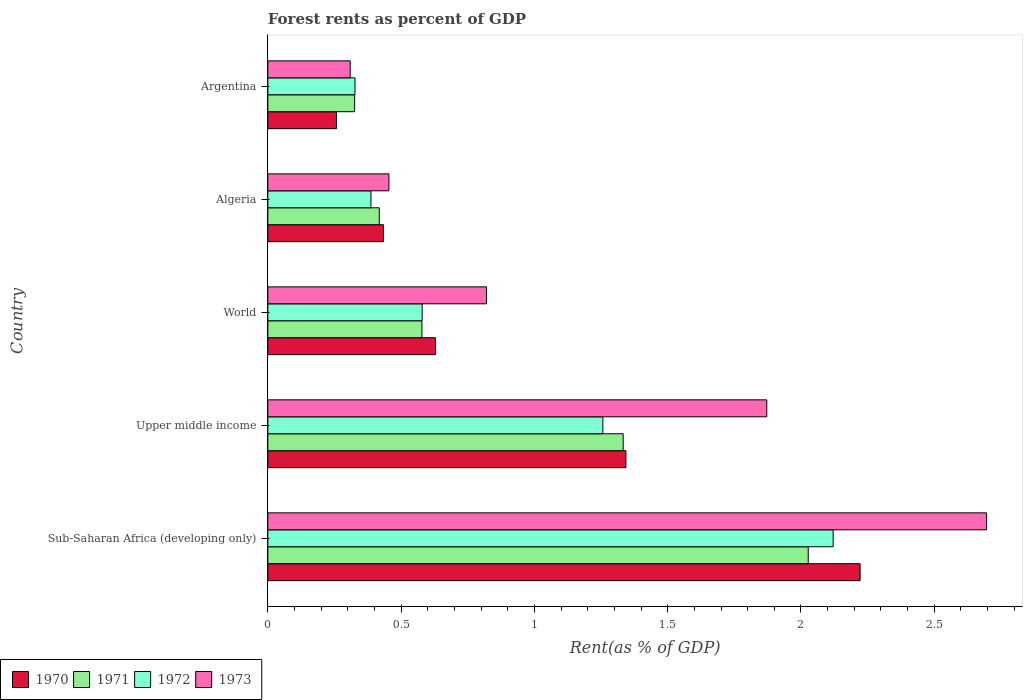How many different coloured bars are there?
Your answer should be very brief. 4. Are the number of bars on each tick of the Y-axis equal?
Provide a succinct answer. Yes. How many bars are there on the 4th tick from the top?
Offer a very short reply. 4. What is the label of the 4th group of bars from the top?
Your answer should be very brief. Upper middle income. What is the forest rent in 1973 in Sub-Saharan Africa (developing only)?
Offer a very short reply. 2.7. Across all countries, what is the maximum forest rent in 1973?
Ensure brevity in your answer.  2.7. Across all countries, what is the minimum forest rent in 1973?
Keep it short and to the point. 0.31. In which country was the forest rent in 1970 maximum?
Keep it short and to the point. Sub-Saharan Africa (developing only). What is the total forest rent in 1972 in the graph?
Keep it short and to the point. 4.67. What is the difference between the forest rent in 1972 in Argentina and that in Upper middle income?
Keep it short and to the point. -0.93. What is the difference between the forest rent in 1973 in World and the forest rent in 1972 in Upper middle income?
Offer a terse response. -0.44. What is the average forest rent in 1973 per country?
Provide a short and direct response. 1.23. What is the difference between the forest rent in 1972 and forest rent in 1971 in Algeria?
Offer a very short reply. -0.03. In how many countries, is the forest rent in 1973 greater than 1.6 %?
Offer a very short reply. 2. What is the ratio of the forest rent in 1972 in Argentina to that in Upper middle income?
Ensure brevity in your answer.  0.26. Is the forest rent in 1971 in Algeria less than that in Argentina?
Ensure brevity in your answer.  No. What is the difference between the highest and the second highest forest rent in 1973?
Offer a very short reply. 0.82. What is the difference between the highest and the lowest forest rent in 1970?
Your response must be concise. 1.96. Is it the case that in every country, the sum of the forest rent in 1971 and forest rent in 1970 is greater than the sum of forest rent in 1973 and forest rent in 1972?
Keep it short and to the point. No. What does the 3rd bar from the bottom in World represents?
Offer a very short reply. 1972. How many bars are there?
Ensure brevity in your answer.  20. Are all the bars in the graph horizontal?
Your answer should be compact. Yes. How many countries are there in the graph?
Make the answer very short. 5. What is the difference between two consecutive major ticks on the X-axis?
Make the answer very short. 0.5. Does the graph contain grids?
Your answer should be very brief. No. How are the legend labels stacked?
Provide a succinct answer. Horizontal. What is the title of the graph?
Your answer should be very brief. Forest rents as percent of GDP. Does "1989" appear as one of the legend labels in the graph?
Offer a terse response. No. What is the label or title of the X-axis?
Your response must be concise. Rent(as % of GDP). What is the Rent(as % of GDP) of 1970 in Sub-Saharan Africa (developing only)?
Your answer should be very brief. 2.22. What is the Rent(as % of GDP) in 1971 in Sub-Saharan Africa (developing only)?
Your answer should be very brief. 2.03. What is the Rent(as % of GDP) in 1972 in Sub-Saharan Africa (developing only)?
Your response must be concise. 2.12. What is the Rent(as % of GDP) of 1973 in Sub-Saharan Africa (developing only)?
Give a very brief answer. 2.7. What is the Rent(as % of GDP) of 1970 in Upper middle income?
Give a very brief answer. 1.34. What is the Rent(as % of GDP) in 1971 in Upper middle income?
Ensure brevity in your answer.  1.33. What is the Rent(as % of GDP) in 1972 in Upper middle income?
Your answer should be very brief. 1.26. What is the Rent(as % of GDP) in 1973 in Upper middle income?
Provide a short and direct response. 1.87. What is the Rent(as % of GDP) of 1970 in World?
Your answer should be compact. 0.63. What is the Rent(as % of GDP) in 1971 in World?
Offer a very short reply. 0.58. What is the Rent(as % of GDP) of 1972 in World?
Provide a succinct answer. 0.58. What is the Rent(as % of GDP) of 1973 in World?
Provide a succinct answer. 0.82. What is the Rent(as % of GDP) in 1970 in Algeria?
Offer a very short reply. 0.43. What is the Rent(as % of GDP) in 1971 in Algeria?
Provide a succinct answer. 0.42. What is the Rent(as % of GDP) of 1972 in Algeria?
Ensure brevity in your answer.  0.39. What is the Rent(as % of GDP) in 1973 in Algeria?
Provide a succinct answer. 0.45. What is the Rent(as % of GDP) in 1970 in Argentina?
Make the answer very short. 0.26. What is the Rent(as % of GDP) of 1971 in Argentina?
Provide a succinct answer. 0.33. What is the Rent(as % of GDP) in 1972 in Argentina?
Your response must be concise. 0.33. What is the Rent(as % of GDP) of 1973 in Argentina?
Offer a terse response. 0.31. Across all countries, what is the maximum Rent(as % of GDP) of 1970?
Your answer should be compact. 2.22. Across all countries, what is the maximum Rent(as % of GDP) of 1971?
Offer a terse response. 2.03. Across all countries, what is the maximum Rent(as % of GDP) in 1972?
Provide a succinct answer. 2.12. Across all countries, what is the maximum Rent(as % of GDP) in 1973?
Your response must be concise. 2.7. Across all countries, what is the minimum Rent(as % of GDP) of 1970?
Your answer should be very brief. 0.26. Across all countries, what is the minimum Rent(as % of GDP) of 1971?
Your answer should be very brief. 0.33. Across all countries, what is the minimum Rent(as % of GDP) of 1972?
Your response must be concise. 0.33. Across all countries, what is the minimum Rent(as % of GDP) in 1973?
Provide a succinct answer. 0.31. What is the total Rent(as % of GDP) in 1970 in the graph?
Make the answer very short. 4.89. What is the total Rent(as % of GDP) in 1971 in the graph?
Make the answer very short. 4.68. What is the total Rent(as % of GDP) of 1972 in the graph?
Offer a terse response. 4.67. What is the total Rent(as % of GDP) of 1973 in the graph?
Keep it short and to the point. 6.15. What is the difference between the Rent(as % of GDP) in 1970 in Sub-Saharan Africa (developing only) and that in Upper middle income?
Ensure brevity in your answer.  0.88. What is the difference between the Rent(as % of GDP) of 1971 in Sub-Saharan Africa (developing only) and that in Upper middle income?
Keep it short and to the point. 0.69. What is the difference between the Rent(as % of GDP) in 1972 in Sub-Saharan Africa (developing only) and that in Upper middle income?
Provide a short and direct response. 0.86. What is the difference between the Rent(as % of GDP) of 1973 in Sub-Saharan Africa (developing only) and that in Upper middle income?
Your answer should be compact. 0.82. What is the difference between the Rent(as % of GDP) of 1970 in Sub-Saharan Africa (developing only) and that in World?
Your answer should be compact. 1.59. What is the difference between the Rent(as % of GDP) of 1971 in Sub-Saharan Africa (developing only) and that in World?
Offer a terse response. 1.45. What is the difference between the Rent(as % of GDP) in 1972 in Sub-Saharan Africa (developing only) and that in World?
Ensure brevity in your answer.  1.54. What is the difference between the Rent(as % of GDP) of 1973 in Sub-Saharan Africa (developing only) and that in World?
Your response must be concise. 1.88. What is the difference between the Rent(as % of GDP) in 1970 in Sub-Saharan Africa (developing only) and that in Algeria?
Provide a succinct answer. 1.79. What is the difference between the Rent(as % of GDP) in 1971 in Sub-Saharan Africa (developing only) and that in Algeria?
Make the answer very short. 1.61. What is the difference between the Rent(as % of GDP) of 1972 in Sub-Saharan Africa (developing only) and that in Algeria?
Provide a succinct answer. 1.73. What is the difference between the Rent(as % of GDP) of 1973 in Sub-Saharan Africa (developing only) and that in Algeria?
Your response must be concise. 2.24. What is the difference between the Rent(as % of GDP) in 1970 in Sub-Saharan Africa (developing only) and that in Argentina?
Your answer should be very brief. 1.96. What is the difference between the Rent(as % of GDP) of 1971 in Sub-Saharan Africa (developing only) and that in Argentina?
Your response must be concise. 1.7. What is the difference between the Rent(as % of GDP) of 1972 in Sub-Saharan Africa (developing only) and that in Argentina?
Make the answer very short. 1.79. What is the difference between the Rent(as % of GDP) in 1973 in Sub-Saharan Africa (developing only) and that in Argentina?
Offer a terse response. 2.39. What is the difference between the Rent(as % of GDP) of 1970 in Upper middle income and that in World?
Provide a short and direct response. 0.71. What is the difference between the Rent(as % of GDP) of 1971 in Upper middle income and that in World?
Your answer should be compact. 0.76. What is the difference between the Rent(as % of GDP) in 1972 in Upper middle income and that in World?
Give a very brief answer. 0.68. What is the difference between the Rent(as % of GDP) in 1973 in Upper middle income and that in World?
Offer a very short reply. 1.05. What is the difference between the Rent(as % of GDP) of 1970 in Upper middle income and that in Algeria?
Make the answer very short. 0.91. What is the difference between the Rent(as % of GDP) in 1971 in Upper middle income and that in Algeria?
Provide a short and direct response. 0.92. What is the difference between the Rent(as % of GDP) in 1972 in Upper middle income and that in Algeria?
Make the answer very short. 0.87. What is the difference between the Rent(as % of GDP) of 1973 in Upper middle income and that in Algeria?
Offer a terse response. 1.42. What is the difference between the Rent(as % of GDP) of 1970 in Upper middle income and that in Argentina?
Your answer should be very brief. 1.09. What is the difference between the Rent(as % of GDP) of 1971 in Upper middle income and that in Argentina?
Offer a very short reply. 1.01. What is the difference between the Rent(as % of GDP) of 1972 in Upper middle income and that in Argentina?
Make the answer very short. 0.93. What is the difference between the Rent(as % of GDP) in 1973 in Upper middle income and that in Argentina?
Keep it short and to the point. 1.56. What is the difference between the Rent(as % of GDP) in 1970 in World and that in Algeria?
Give a very brief answer. 0.2. What is the difference between the Rent(as % of GDP) of 1971 in World and that in Algeria?
Ensure brevity in your answer.  0.16. What is the difference between the Rent(as % of GDP) in 1972 in World and that in Algeria?
Your answer should be very brief. 0.19. What is the difference between the Rent(as % of GDP) of 1973 in World and that in Algeria?
Provide a succinct answer. 0.37. What is the difference between the Rent(as % of GDP) in 1970 in World and that in Argentina?
Your response must be concise. 0.37. What is the difference between the Rent(as % of GDP) of 1971 in World and that in Argentina?
Provide a succinct answer. 0.25. What is the difference between the Rent(as % of GDP) of 1972 in World and that in Argentina?
Provide a short and direct response. 0.25. What is the difference between the Rent(as % of GDP) in 1973 in World and that in Argentina?
Offer a very short reply. 0.51. What is the difference between the Rent(as % of GDP) of 1970 in Algeria and that in Argentina?
Offer a very short reply. 0.18. What is the difference between the Rent(as % of GDP) of 1971 in Algeria and that in Argentina?
Provide a short and direct response. 0.09. What is the difference between the Rent(as % of GDP) of 1972 in Algeria and that in Argentina?
Provide a succinct answer. 0.06. What is the difference between the Rent(as % of GDP) of 1973 in Algeria and that in Argentina?
Keep it short and to the point. 0.15. What is the difference between the Rent(as % of GDP) of 1970 in Sub-Saharan Africa (developing only) and the Rent(as % of GDP) of 1971 in Upper middle income?
Ensure brevity in your answer.  0.89. What is the difference between the Rent(as % of GDP) of 1970 in Sub-Saharan Africa (developing only) and the Rent(as % of GDP) of 1972 in Upper middle income?
Your answer should be very brief. 0.97. What is the difference between the Rent(as % of GDP) in 1970 in Sub-Saharan Africa (developing only) and the Rent(as % of GDP) in 1973 in Upper middle income?
Your answer should be compact. 0.35. What is the difference between the Rent(as % of GDP) of 1971 in Sub-Saharan Africa (developing only) and the Rent(as % of GDP) of 1972 in Upper middle income?
Your answer should be compact. 0.77. What is the difference between the Rent(as % of GDP) of 1971 in Sub-Saharan Africa (developing only) and the Rent(as % of GDP) of 1973 in Upper middle income?
Your response must be concise. 0.16. What is the difference between the Rent(as % of GDP) of 1972 in Sub-Saharan Africa (developing only) and the Rent(as % of GDP) of 1973 in Upper middle income?
Keep it short and to the point. 0.25. What is the difference between the Rent(as % of GDP) of 1970 in Sub-Saharan Africa (developing only) and the Rent(as % of GDP) of 1971 in World?
Offer a terse response. 1.64. What is the difference between the Rent(as % of GDP) in 1970 in Sub-Saharan Africa (developing only) and the Rent(as % of GDP) in 1972 in World?
Your response must be concise. 1.64. What is the difference between the Rent(as % of GDP) in 1970 in Sub-Saharan Africa (developing only) and the Rent(as % of GDP) in 1973 in World?
Offer a very short reply. 1.4. What is the difference between the Rent(as % of GDP) in 1971 in Sub-Saharan Africa (developing only) and the Rent(as % of GDP) in 1972 in World?
Offer a terse response. 1.45. What is the difference between the Rent(as % of GDP) of 1971 in Sub-Saharan Africa (developing only) and the Rent(as % of GDP) of 1973 in World?
Keep it short and to the point. 1.21. What is the difference between the Rent(as % of GDP) of 1972 in Sub-Saharan Africa (developing only) and the Rent(as % of GDP) of 1973 in World?
Offer a very short reply. 1.3. What is the difference between the Rent(as % of GDP) of 1970 in Sub-Saharan Africa (developing only) and the Rent(as % of GDP) of 1971 in Algeria?
Your answer should be very brief. 1.8. What is the difference between the Rent(as % of GDP) of 1970 in Sub-Saharan Africa (developing only) and the Rent(as % of GDP) of 1972 in Algeria?
Give a very brief answer. 1.84. What is the difference between the Rent(as % of GDP) of 1970 in Sub-Saharan Africa (developing only) and the Rent(as % of GDP) of 1973 in Algeria?
Provide a succinct answer. 1.77. What is the difference between the Rent(as % of GDP) of 1971 in Sub-Saharan Africa (developing only) and the Rent(as % of GDP) of 1972 in Algeria?
Your answer should be very brief. 1.64. What is the difference between the Rent(as % of GDP) in 1971 in Sub-Saharan Africa (developing only) and the Rent(as % of GDP) in 1973 in Algeria?
Make the answer very short. 1.57. What is the difference between the Rent(as % of GDP) in 1972 in Sub-Saharan Africa (developing only) and the Rent(as % of GDP) in 1973 in Algeria?
Your response must be concise. 1.67. What is the difference between the Rent(as % of GDP) in 1970 in Sub-Saharan Africa (developing only) and the Rent(as % of GDP) in 1971 in Argentina?
Provide a short and direct response. 1.9. What is the difference between the Rent(as % of GDP) in 1970 in Sub-Saharan Africa (developing only) and the Rent(as % of GDP) in 1972 in Argentina?
Keep it short and to the point. 1.9. What is the difference between the Rent(as % of GDP) in 1970 in Sub-Saharan Africa (developing only) and the Rent(as % of GDP) in 1973 in Argentina?
Give a very brief answer. 1.91. What is the difference between the Rent(as % of GDP) in 1971 in Sub-Saharan Africa (developing only) and the Rent(as % of GDP) in 1972 in Argentina?
Provide a succinct answer. 1.7. What is the difference between the Rent(as % of GDP) of 1971 in Sub-Saharan Africa (developing only) and the Rent(as % of GDP) of 1973 in Argentina?
Ensure brevity in your answer.  1.72. What is the difference between the Rent(as % of GDP) of 1972 in Sub-Saharan Africa (developing only) and the Rent(as % of GDP) of 1973 in Argentina?
Provide a succinct answer. 1.81. What is the difference between the Rent(as % of GDP) in 1970 in Upper middle income and the Rent(as % of GDP) in 1971 in World?
Give a very brief answer. 0.77. What is the difference between the Rent(as % of GDP) in 1970 in Upper middle income and the Rent(as % of GDP) in 1972 in World?
Ensure brevity in your answer.  0.76. What is the difference between the Rent(as % of GDP) of 1970 in Upper middle income and the Rent(as % of GDP) of 1973 in World?
Your answer should be very brief. 0.52. What is the difference between the Rent(as % of GDP) of 1971 in Upper middle income and the Rent(as % of GDP) of 1972 in World?
Provide a short and direct response. 0.75. What is the difference between the Rent(as % of GDP) in 1971 in Upper middle income and the Rent(as % of GDP) in 1973 in World?
Ensure brevity in your answer.  0.51. What is the difference between the Rent(as % of GDP) in 1972 in Upper middle income and the Rent(as % of GDP) in 1973 in World?
Offer a terse response. 0.44. What is the difference between the Rent(as % of GDP) of 1970 in Upper middle income and the Rent(as % of GDP) of 1971 in Algeria?
Your response must be concise. 0.93. What is the difference between the Rent(as % of GDP) of 1970 in Upper middle income and the Rent(as % of GDP) of 1972 in Algeria?
Offer a very short reply. 0.96. What is the difference between the Rent(as % of GDP) of 1970 in Upper middle income and the Rent(as % of GDP) of 1973 in Algeria?
Offer a terse response. 0.89. What is the difference between the Rent(as % of GDP) in 1971 in Upper middle income and the Rent(as % of GDP) in 1972 in Algeria?
Offer a very short reply. 0.95. What is the difference between the Rent(as % of GDP) of 1971 in Upper middle income and the Rent(as % of GDP) of 1973 in Algeria?
Keep it short and to the point. 0.88. What is the difference between the Rent(as % of GDP) in 1972 in Upper middle income and the Rent(as % of GDP) in 1973 in Algeria?
Keep it short and to the point. 0.8. What is the difference between the Rent(as % of GDP) of 1970 in Upper middle income and the Rent(as % of GDP) of 1971 in Argentina?
Your response must be concise. 1.02. What is the difference between the Rent(as % of GDP) of 1970 in Upper middle income and the Rent(as % of GDP) of 1972 in Argentina?
Provide a succinct answer. 1.02. What is the difference between the Rent(as % of GDP) in 1970 in Upper middle income and the Rent(as % of GDP) in 1973 in Argentina?
Provide a succinct answer. 1.03. What is the difference between the Rent(as % of GDP) in 1971 in Upper middle income and the Rent(as % of GDP) in 1972 in Argentina?
Provide a succinct answer. 1.01. What is the difference between the Rent(as % of GDP) in 1971 in Upper middle income and the Rent(as % of GDP) in 1973 in Argentina?
Make the answer very short. 1.02. What is the difference between the Rent(as % of GDP) of 1972 in Upper middle income and the Rent(as % of GDP) of 1973 in Argentina?
Make the answer very short. 0.95. What is the difference between the Rent(as % of GDP) of 1970 in World and the Rent(as % of GDP) of 1971 in Algeria?
Your response must be concise. 0.21. What is the difference between the Rent(as % of GDP) of 1970 in World and the Rent(as % of GDP) of 1972 in Algeria?
Your answer should be very brief. 0.24. What is the difference between the Rent(as % of GDP) of 1970 in World and the Rent(as % of GDP) of 1973 in Algeria?
Offer a terse response. 0.17. What is the difference between the Rent(as % of GDP) in 1971 in World and the Rent(as % of GDP) in 1972 in Algeria?
Your answer should be compact. 0.19. What is the difference between the Rent(as % of GDP) in 1971 in World and the Rent(as % of GDP) in 1973 in Algeria?
Provide a short and direct response. 0.12. What is the difference between the Rent(as % of GDP) in 1972 in World and the Rent(as % of GDP) in 1973 in Algeria?
Provide a succinct answer. 0.12. What is the difference between the Rent(as % of GDP) in 1970 in World and the Rent(as % of GDP) in 1971 in Argentina?
Provide a short and direct response. 0.3. What is the difference between the Rent(as % of GDP) of 1970 in World and the Rent(as % of GDP) of 1972 in Argentina?
Provide a succinct answer. 0.3. What is the difference between the Rent(as % of GDP) in 1970 in World and the Rent(as % of GDP) in 1973 in Argentina?
Ensure brevity in your answer.  0.32. What is the difference between the Rent(as % of GDP) in 1971 in World and the Rent(as % of GDP) in 1972 in Argentina?
Offer a very short reply. 0.25. What is the difference between the Rent(as % of GDP) of 1971 in World and the Rent(as % of GDP) of 1973 in Argentina?
Your response must be concise. 0.27. What is the difference between the Rent(as % of GDP) of 1972 in World and the Rent(as % of GDP) of 1973 in Argentina?
Offer a terse response. 0.27. What is the difference between the Rent(as % of GDP) of 1970 in Algeria and the Rent(as % of GDP) of 1971 in Argentina?
Your response must be concise. 0.11. What is the difference between the Rent(as % of GDP) of 1970 in Algeria and the Rent(as % of GDP) of 1972 in Argentina?
Make the answer very short. 0.11. What is the difference between the Rent(as % of GDP) of 1970 in Algeria and the Rent(as % of GDP) of 1973 in Argentina?
Keep it short and to the point. 0.12. What is the difference between the Rent(as % of GDP) in 1971 in Algeria and the Rent(as % of GDP) in 1972 in Argentina?
Your answer should be very brief. 0.09. What is the difference between the Rent(as % of GDP) in 1971 in Algeria and the Rent(as % of GDP) in 1973 in Argentina?
Provide a succinct answer. 0.11. What is the difference between the Rent(as % of GDP) in 1972 in Algeria and the Rent(as % of GDP) in 1973 in Argentina?
Your response must be concise. 0.08. What is the average Rent(as % of GDP) in 1970 per country?
Make the answer very short. 0.98. What is the average Rent(as % of GDP) of 1971 per country?
Keep it short and to the point. 0.94. What is the average Rent(as % of GDP) of 1972 per country?
Provide a succinct answer. 0.93. What is the average Rent(as % of GDP) of 1973 per country?
Ensure brevity in your answer.  1.23. What is the difference between the Rent(as % of GDP) of 1970 and Rent(as % of GDP) of 1971 in Sub-Saharan Africa (developing only)?
Provide a succinct answer. 0.19. What is the difference between the Rent(as % of GDP) in 1970 and Rent(as % of GDP) in 1972 in Sub-Saharan Africa (developing only)?
Give a very brief answer. 0.1. What is the difference between the Rent(as % of GDP) of 1970 and Rent(as % of GDP) of 1973 in Sub-Saharan Africa (developing only)?
Your response must be concise. -0.47. What is the difference between the Rent(as % of GDP) in 1971 and Rent(as % of GDP) in 1972 in Sub-Saharan Africa (developing only)?
Your answer should be very brief. -0.09. What is the difference between the Rent(as % of GDP) in 1971 and Rent(as % of GDP) in 1973 in Sub-Saharan Africa (developing only)?
Your answer should be compact. -0.67. What is the difference between the Rent(as % of GDP) in 1972 and Rent(as % of GDP) in 1973 in Sub-Saharan Africa (developing only)?
Provide a succinct answer. -0.58. What is the difference between the Rent(as % of GDP) of 1970 and Rent(as % of GDP) of 1971 in Upper middle income?
Ensure brevity in your answer.  0.01. What is the difference between the Rent(as % of GDP) in 1970 and Rent(as % of GDP) in 1972 in Upper middle income?
Provide a short and direct response. 0.09. What is the difference between the Rent(as % of GDP) of 1970 and Rent(as % of GDP) of 1973 in Upper middle income?
Offer a very short reply. -0.53. What is the difference between the Rent(as % of GDP) in 1971 and Rent(as % of GDP) in 1972 in Upper middle income?
Offer a very short reply. 0.08. What is the difference between the Rent(as % of GDP) of 1971 and Rent(as % of GDP) of 1973 in Upper middle income?
Make the answer very short. -0.54. What is the difference between the Rent(as % of GDP) of 1972 and Rent(as % of GDP) of 1973 in Upper middle income?
Offer a very short reply. -0.61. What is the difference between the Rent(as % of GDP) of 1970 and Rent(as % of GDP) of 1971 in World?
Offer a terse response. 0.05. What is the difference between the Rent(as % of GDP) in 1970 and Rent(as % of GDP) in 1972 in World?
Offer a terse response. 0.05. What is the difference between the Rent(as % of GDP) of 1970 and Rent(as % of GDP) of 1973 in World?
Your answer should be compact. -0.19. What is the difference between the Rent(as % of GDP) in 1971 and Rent(as % of GDP) in 1972 in World?
Ensure brevity in your answer.  -0. What is the difference between the Rent(as % of GDP) of 1971 and Rent(as % of GDP) of 1973 in World?
Provide a succinct answer. -0.24. What is the difference between the Rent(as % of GDP) in 1972 and Rent(as % of GDP) in 1973 in World?
Your answer should be compact. -0.24. What is the difference between the Rent(as % of GDP) of 1970 and Rent(as % of GDP) of 1971 in Algeria?
Offer a terse response. 0.02. What is the difference between the Rent(as % of GDP) in 1970 and Rent(as % of GDP) in 1972 in Algeria?
Offer a very short reply. 0.05. What is the difference between the Rent(as % of GDP) of 1970 and Rent(as % of GDP) of 1973 in Algeria?
Offer a terse response. -0.02. What is the difference between the Rent(as % of GDP) of 1971 and Rent(as % of GDP) of 1972 in Algeria?
Ensure brevity in your answer.  0.03. What is the difference between the Rent(as % of GDP) of 1971 and Rent(as % of GDP) of 1973 in Algeria?
Give a very brief answer. -0.04. What is the difference between the Rent(as % of GDP) of 1972 and Rent(as % of GDP) of 1973 in Algeria?
Provide a short and direct response. -0.07. What is the difference between the Rent(as % of GDP) in 1970 and Rent(as % of GDP) in 1971 in Argentina?
Provide a succinct answer. -0.07. What is the difference between the Rent(as % of GDP) in 1970 and Rent(as % of GDP) in 1972 in Argentina?
Make the answer very short. -0.07. What is the difference between the Rent(as % of GDP) in 1970 and Rent(as % of GDP) in 1973 in Argentina?
Provide a succinct answer. -0.05. What is the difference between the Rent(as % of GDP) in 1971 and Rent(as % of GDP) in 1972 in Argentina?
Your response must be concise. -0. What is the difference between the Rent(as % of GDP) of 1971 and Rent(as % of GDP) of 1973 in Argentina?
Offer a very short reply. 0.02. What is the difference between the Rent(as % of GDP) in 1972 and Rent(as % of GDP) in 1973 in Argentina?
Ensure brevity in your answer.  0.02. What is the ratio of the Rent(as % of GDP) of 1970 in Sub-Saharan Africa (developing only) to that in Upper middle income?
Ensure brevity in your answer.  1.65. What is the ratio of the Rent(as % of GDP) in 1971 in Sub-Saharan Africa (developing only) to that in Upper middle income?
Offer a terse response. 1.52. What is the ratio of the Rent(as % of GDP) in 1972 in Sub-Saharan Africa (developing only) to that in Upper middle income?
Your answer should be very brief. 1.69. What is the ratio of the Rent(as % of GDP) of 1973 in Sub-Saharan Africa (developing only) to that in Upper middle income?
Your response must be concise. 1.44. What is the ratio of the Rent(as % of GDP) in 1970 in Sub-Saharan Africa (developing only) to that in World?
Your answer should be very brief. 3.53. What is the ratio of the Rent(as % of GDP) in 1971 in Sub-Saharan Africa (developing only) to that in World?
Provide a short and direct response. 3.51. What is the ratio of the Rent(as % of GDP) in 1972 in Sub-Saharan Africa (developing only) to that in World?
Your answer should be very brief. 3.66. What is the ratio of the Rent(as % of GDP) in 1973 in Sub-Saharan Africa (developing only) to that in World?
Ensure brevity in your answer.  3.29. What is the ratio of the Rent(as % of GDP) in 1970 in Sub-Saharan Africa (developing only) to that in Algeria?
Give a very brief answer. 5.12. What is the ratio of the Rent(as % of GDP) in 1971 in Sub-Saharan Africa (developing only) to that in Algeria?
Make the answer very short. 4.85. What is the ratio of the Rent(as % of GDP) of 1972 in Sub-Saharan Africa (developing only) to that in Algeria?
Provide a short and direct response. 5.48. What is the ratio of the Rent(as % of GDP) in 1973 in Sub-Saharan Africa (developing only) to that in Algeria?
Make the answer very short. 5.94. What is the ratio of the Rent(as % of GDP) of 1970 in Sub-Saharan Africa (developing only) to that in Argentina?
Your answer should be very brief. 8.63. What is the ratio of the Rent(as % of GDP) of 1971 in Sub-Saharan Africa (developing only) to that in Argentina?
Provide a succinct answer. 6.23. What is the ratio of the Rent(as % of GDP) of 1972 in Sub-Saharan Africa (developing only) to that in Argentina?
Keep it short and to the point. 6.49. What is the ratio of the Rent(as % of GDP) of 1973 in Sub-Saharan Africa (developing only) to that in Argentina?
Make the answer very short. 8.73. What is the ratio of the Rent(as % of GDP) in 1970 in Upper middle income to that in World?
Ensure brevity in your answer.  2.14. What is the ratio of the Rent(as % of GDP) in 1971 in Upper middle income to that in World?
Offer a terse response. 2.31. What is the ratio of the Rent(as % of GDP) of 1972 in Upper middle income to that in World?
Provide a short and direct response. 2.17. What is the ratio of the Rent(as % of GDP) of 1973 in Upper middle income to that in World?
Give a very brief answer. 2.28. What is the ratio of the Rent(as % of GDP) in 1970 in Upper middle income to that in Algeria?
Offer a terse response. 3.1. What is the ratio of the Rent(as % of GDP) of 1971 in Upper middle income to that in Algeria?
Give a very brief answer. 3.19. What is the ratio of the Rent(as % of GDP) of 1972 in Upper middle income to that in Algeria?
Provide a succinct answer. 3.25. What is the ratio of the Rent(as % of GDP) of 1973 in Upper middle income to that in Algeria?
Provide a succinct answer. 4.12. What is the ratio of the Rent(as % of GDP) of 1970 in Upper middle income to that in Argentina?
Give a very brief answer. 5.22. What is the ratio of the Rent(as % of GDP) of 1971 in Upper middle income to that in Argentina?
Make the answer very short. 4.1. What is the ratio of the Rent(as % of GDP) of 1972 in Upper middle income to that in Argentina?
Make the answer very short. 3.84. What is the ratio of the Rent(as % of GDP) of 1973 in Upper middle income to that in Argentina?
Provide a succinct answer. 6.06. What is the ratio of the Rent(as % of GDP) of 1970 in World to that in Algeria?
Your response must be concise. 1.45. What is the ratio of the Rent(as % of GDP) of 1971 in World to that in Algeria?
Your answer should be very brief. 1.38. What is the ratio of the Rent(as % of GDP) in 1972 in World to that in Algeria?
Offer a terse response. 1.5. What is the ratio of the Rent(as % of GDP) of 1973 in World to that in Algeria?
Your answer should be compact. 1.81. What is the ratio of the Rent(as % of GDP) in 1970 in World to that in Argentina?
Your answer should be very brief. 2.44. What is the ratio of the Rent(as % of GDP) of 1971 in World to that in Argentina?
Give a very brief answer. 1.78. What is the ratio of the Rent(as % of GDP) in 1972 in World to that in Argentina?
Keep it short and to the point. 1.77. What is the ratio of the Rent(as % of GDP) in 1973 in World to that in Argentina?
Give a very brief answer. 2.66. What is the ratio of the Rent(as % of GDP) of 1970 in Algeria to that in Argentina?
Give a very brief answer. 1.69. What is the ratio of the Rent(as % of GDP) in 1971 in Algeria to that in Argentina?
Make the answer very short. 1.28. What is the ratio of the Rent(as % of GDP) of 1972 in Algeria to that in Argentina?
Your answer should be compact. 1.18. What is the ratio of the Rent(as % of GDP) in 1973 in Algeria to that in Argentina?
Offer a terse response. 1.47. What is the difference between the highest and the second highest Rent(as % of GDP) of 1970?
Make the answer very short. 0.88. What is the difference between the highest and the second highest Rent(as % of GDP) in 1971?
Ensure brevity in your answer.  0.69. What is the difference between the highest and the second highest Rent(as % of GDP) of 1972?
Make the answer very short. 0.86. What is the difference between the highest and the second highest Rent(as % of GDP) of 1973?
Your answer should be compact. 0.82. What is the difference between the highest and the lowest Rent(as % of GDP) in 1970?
Your answer should be compact. 1.96. What is the difference between the highest and the lowest Rent(as % of GDP) in 1971?
Your answer should be very brief. 1.7. What is the difference between the highest and the lowest Rent(as % of GDP) in 1972?
Ensure brevity in your answer.  1.79. What is the difference between the highest and the lowest Rent(as % of GDP) of 1973?
Make the answer very short. 2.39. 